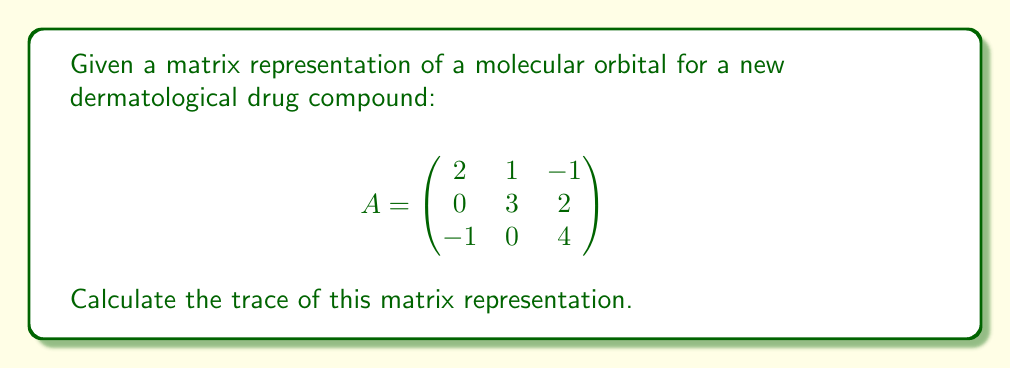What is the answer to this math problem? To calculate the trace of a matrix, we sum the elements along the main diagonal (from top-left to bottom-right).

Step 1: Identify the elements on the main diagonal:
- Top-left element: $a_{11} = 2$
- Middle element: $a_{22} = 3$
- Bottom-right element: $a_{33} = 4$

Step 2: Sum these diagonal elements:

$\text{Trace}(A) = a_{11} + a_{22} + a_{33}$

$\text{Trace}(A) = 2 + 3 + 4$

Step 3: Perform the addition:

$\text{Trace}(A) = 9$

This trace value represents the sum of the eigenvalues of the matrix and can provide insights into the molecular orbital's energy levels, which is crucial for understanding the drug compound's reactivity and stability in dermatological applications.
Answer: $9$ 